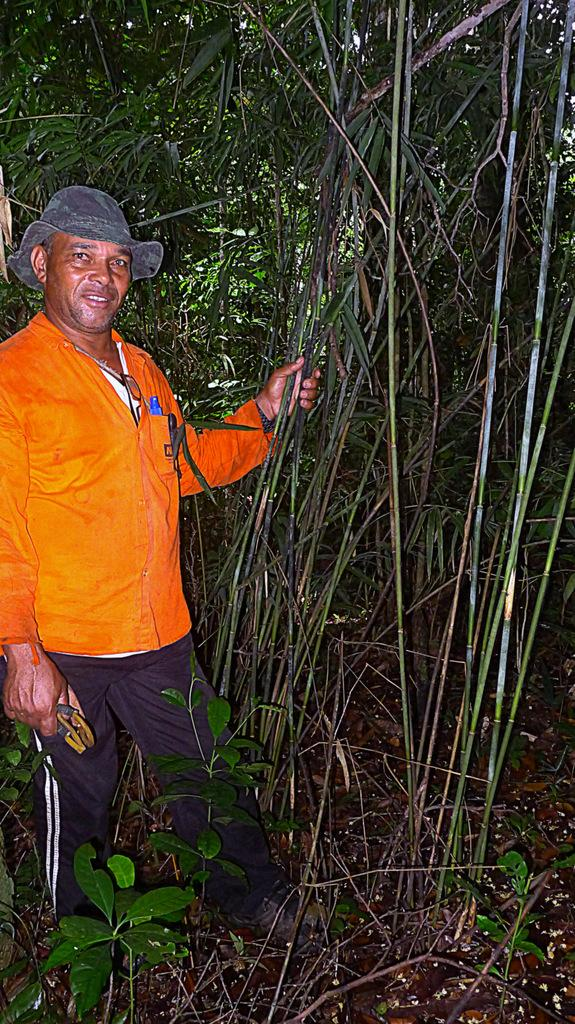What is the main subject in the foreground of the image? There is a man standing in the foreground of the image. What is the man holding in the image? The man is holding a cutter-like object. What type of vegetation can be seen in the image? There are plants in the image. What can be seen in the background of the image? There are trees in the background of the image. How many basketballs can be seen on the plate in the image? There is no plate or basketball present in the image. 